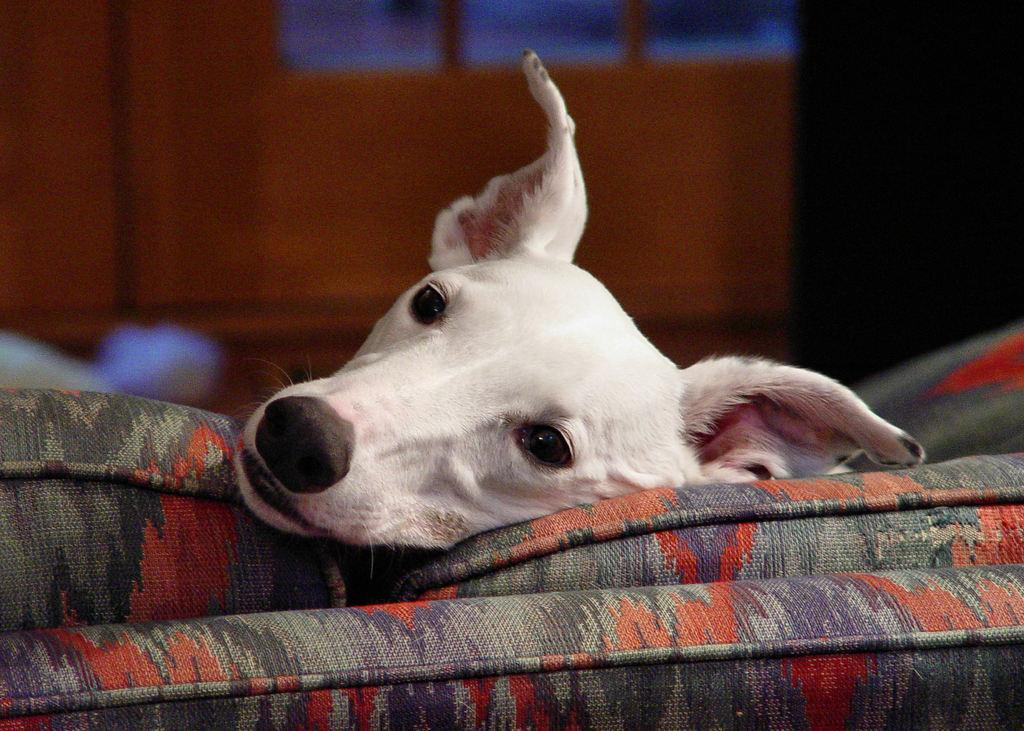What is the main subject of the image? The main subject of the image is a dog's head. What is the dog's head resting on? The dog's head is on a colorful object. Can you describe the background of the image? The background of the image is blurry. What type of wool is being spun by the plants in the image? There are no plants or wool present in the image; it features a dog's head on a colorful object with a blurry background. 